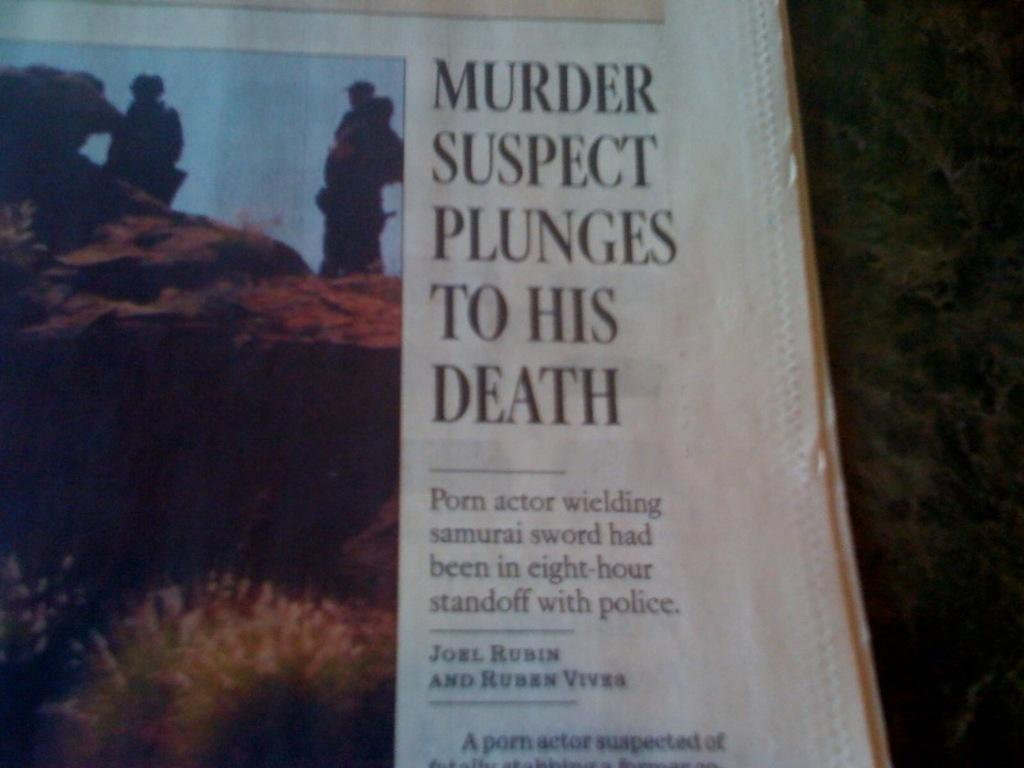<image>
Create a compact narrative representing the image presented. the word murder is on top of the paper 